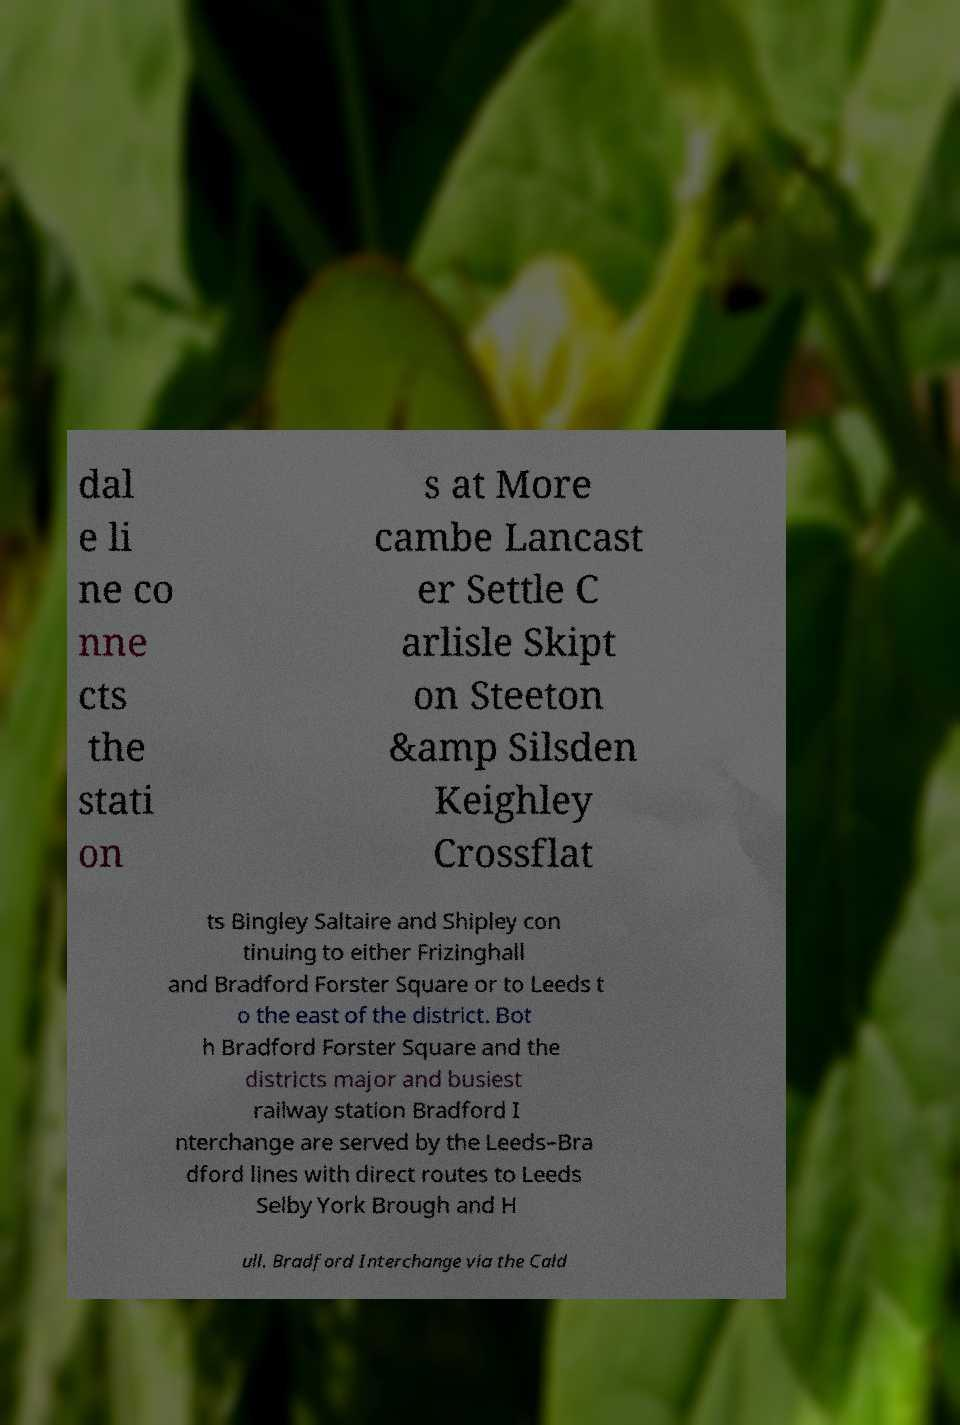I need the written content from this picture converted into text. Can you do that? dal e li ne co nne cts the stati on s at More cambe Lancast er Settle C arlisle Skipt on Steeton &amp Silsden Keighley Crossflat ts Bingley Saltaire and Shipley con tinuing to either Frizinghall and Bradford Forster Square or to Leeds t o the east of the district. Bot h Bradford Forster Square and the districts major and busiest railway station Bradford I nterchange are served by the Leeds–Bra dford lines with direct routes to Leeds Selby York Brough and H ull. Bradford Interchange via the Cald 